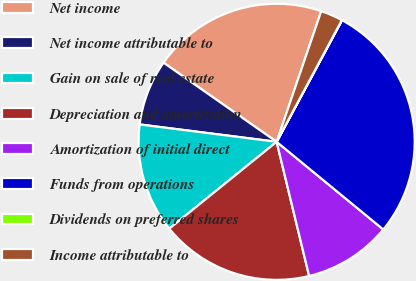<chart> <loc_0><loc_0><loc_500><loc_500><pie_chart><fcel>Net income<fcel>Net income attributable to<fcel>Gain on sale of real estate<fcel>Depreciation and amortization<fcel>Amortization of initial direct<fcel>Funds from operations<fcel>Dividends on preferred shares<fcel>Income attributable to<nl><fcel>20.51%<fcel>7.71%<fcel>12.83%<fcel>17.95%<fcel>10.27%<fcel>28.09%<fcel>0.03%<fcel>2.59%<nl></chart> 